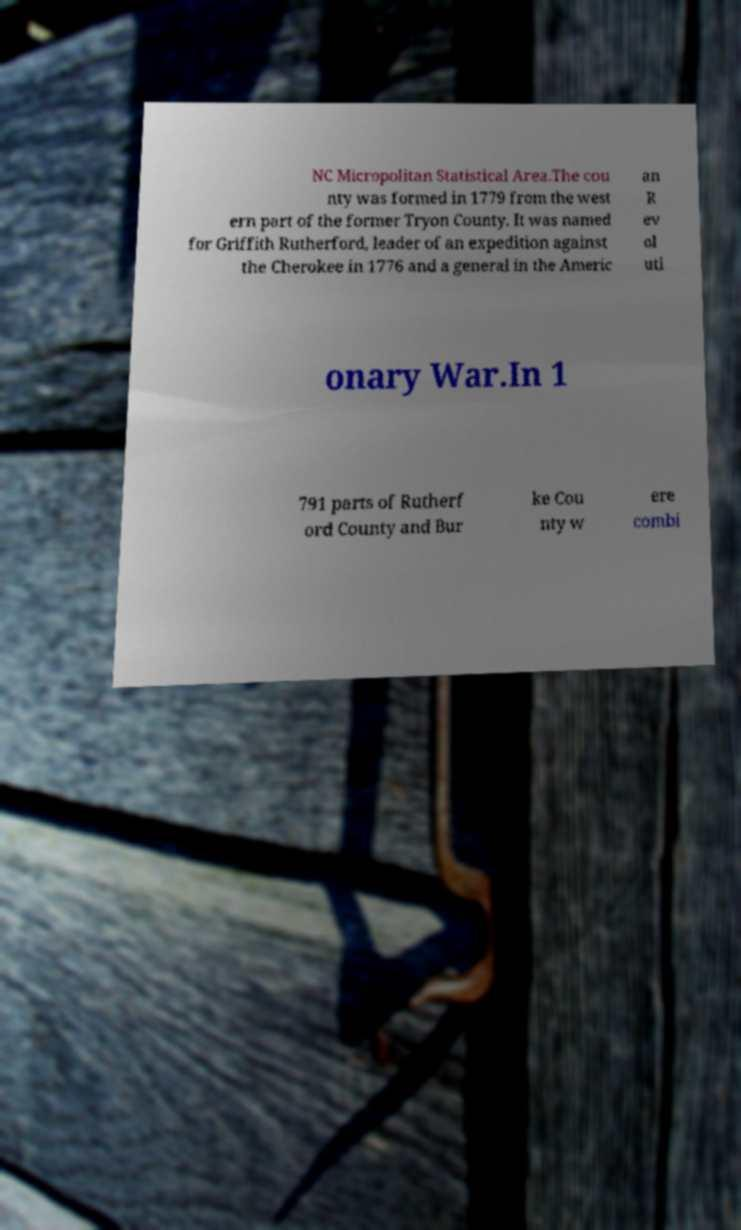I need the written content from this picture converted into text. Can you do that? NC Micropolitan Statistical Area.The cou nty was formed in 1779 from the west ern part of the former Tryon County. It was named for Griffith Rutherford, leader of an expedition against the Cherokee in 1776 and a general in the Americ an R ev ol uti onary War.In 1 791 parts of Rutherf ord County and Bur ke Cou nty w ere combi 